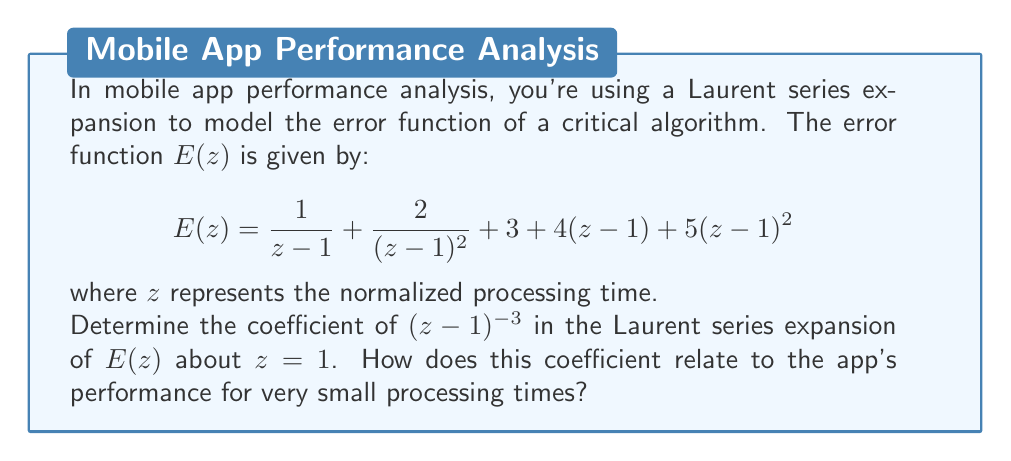Could you help me with this problem? To solve this problem, we'll follow these steps:

1) First, recall that the Laurent series expansion of a function $f(z)$ about a point $a$ has the general form:

   $$f(z) = \sum_{n=-\infty}^{\infty} c_n(z-a)^n$$

2) In our case, $a=1$, and we're looking for the coefficient of $(z-1)^{-3}$.

3) Let's examine each term of $E(z)$:

   a) $\frac{1}{z-1} = (z-1)^{-1}$
   b) $\frac{2}{(z-1)^2} = 2(z-1)^{-2}$
   c) $3$ is already in the correct form
   d) $4(z-1)$ is already in the correct form
   e) $5(z-1)^2$ is already in the correct form

4) None of these terms contain $(z-1)^{-3}$, so the coefficient we're looking for is 0.

5) Regarding app performance:
   - Negative powers in a Laurent series typically represent behavior as $z$ approaches the expansion point (in this case, as $z$ approaches 1).
   - The absence of a $(z-1)^{-3}$ term (and any higher negative powers) suggests that the error doesn't grow extremely rapidly as the processing time approaches the normalized value of 1.
   - The most significant term for small processing times would be the $(z-1)^{-2}$ term, indicating a quadratic growth in error as $z$ approaches 1 from below.
Answer: 0; indicates moderate error growth for small processing times 